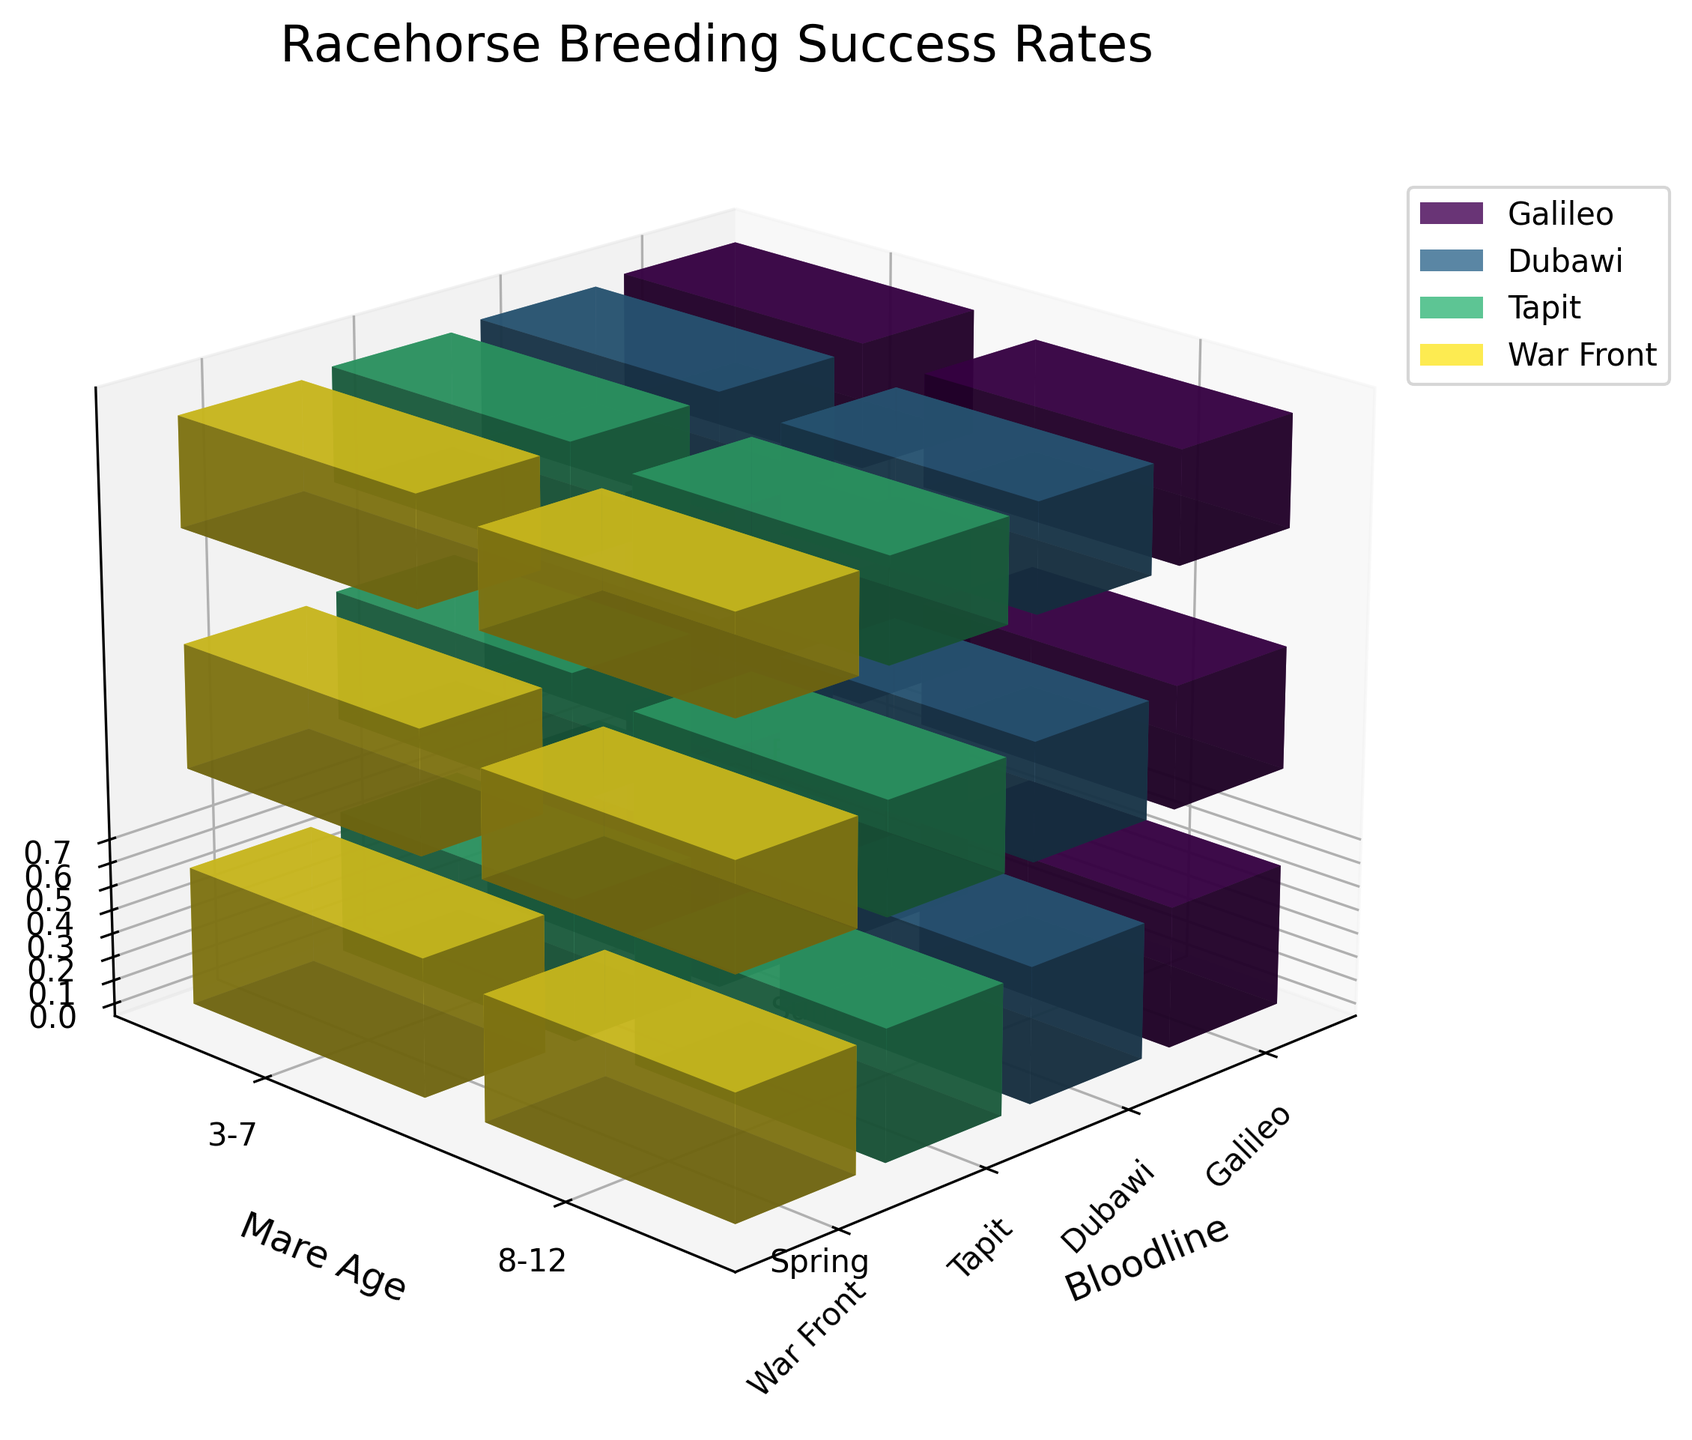Which bloodline has the highest success rate in Spring for mares aged 3-7? Look for the highest bar among the 3-7-year-old mares in the Spring season, paying attention to each bloodline's color-coded bar.
Answer: Galileo What's the overall trend in success rates across seasons for mares aged 8-12 in the Dubawi bloodline? Compare the heights of the bars for Dubawi mares aged 8-12 across Spring, Summer, and Fall. Note if the bars decrease, increase, or remain constant.
Answer: Decreasing How does the success rate of Maritime bloodline in Summer for mares aged 3-7 compare with Galileo's in the same conditions? Identify the bars for Maritime and Galileo under the Summer season for mares aged 3-7 and compare their heights.
Answer: Galileo is higher Which bloodline has the lowest success rate overall? Examine the bars corresponding to all bloodlines and identify the one consistently having the smallest bar heights across all conditions.
Answer: War Front What is the difference in success rates between the youngest and oldest mares in the Tapit bloodline during Fall? Locate bars for Tapit in the Fall, then measure and compare heights for 3-7-year-old mares and 8-12-year-old mares, and find the difference.
Answer: 0.05 Considering the figure, during which season do mares aged 3-7 have the highest success rates, and which bloodline achieves this? Identify and compare the highest bar among all bloodlines for the 3-7 age group across Spring, Summer, and Fall seasons.
Answer: Spring, Galileo What's the average success rate for mares aged 8-12 across all bloodlines in Summer? Sum the heights of Summer bars for mares aged 8-12 from each bloodline and divide by the number of bloodlines.
Answer: 0.48 Does the success rate for War Front mares aged 3-7 show an increasing, decreasing, or constant trend across seasons? Look at War Front bars for mares aged 3-7 and compare their heights from Spring, Summer to Fall.
Answer: Decreasing Which bloodline shows the least variation in success rates across seasons for mares aged 3-7? Evaluate the height differences of the bars across Spring, Summer, and Fall for each bloodline and determine the smallest variation.
Answer: Dubawi 